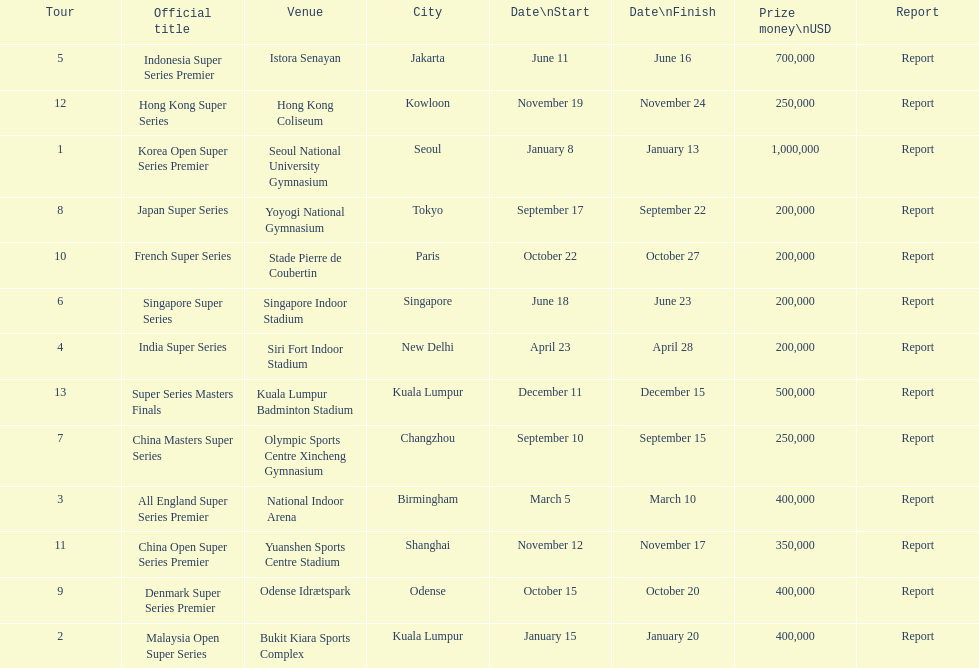How many occur in the last six months of the year? 7. 